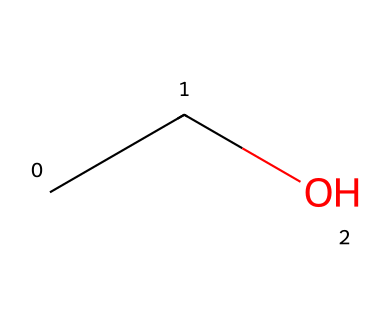What is the chemical name of this compound? The SMILES representation provided, "CCO", corresponds to ethanol, which is the accepted IUPAC name for this compound.
Answer: ethanol How many carbon atoms are in this molecule? Analyzing the SMILES string "CCO", we see "CC" represents two carbon atoms. Thus, there are two carbon atoms in ethanol.
Answer: 2 How many hydrogen atoms are present in this structure? From the SMILES notation "CCO", two carbon atoms are connected to a hydroxyl group. Each carbon in ethanol is saturated, leading to the formula C2H5OH, which has six hydrogen atoms.
Answer: 6 What type of functional group is present in this molecule? The presence of the hydroxyl group (-OH) is identified in the SMILES string through the "O" at the end. This indicates that ethanol is classified as an alcohol.
Answer: alcohol Is ethanol a polar molecule? The presence of the hydroxyl group (-OH) contributes to a significant dipole moment in the molecule, indicating that ethanol has polar characteristics.
Answer: yes Why is ethanol considered a non-electrolyte? Non-electrolytes do not dissociate into ions in solution. Ethanol remains intact as molecules without forming charged particles when dissolved in water, thus it behaves as a non-electrolyte.
Answer: non-electrolyte 